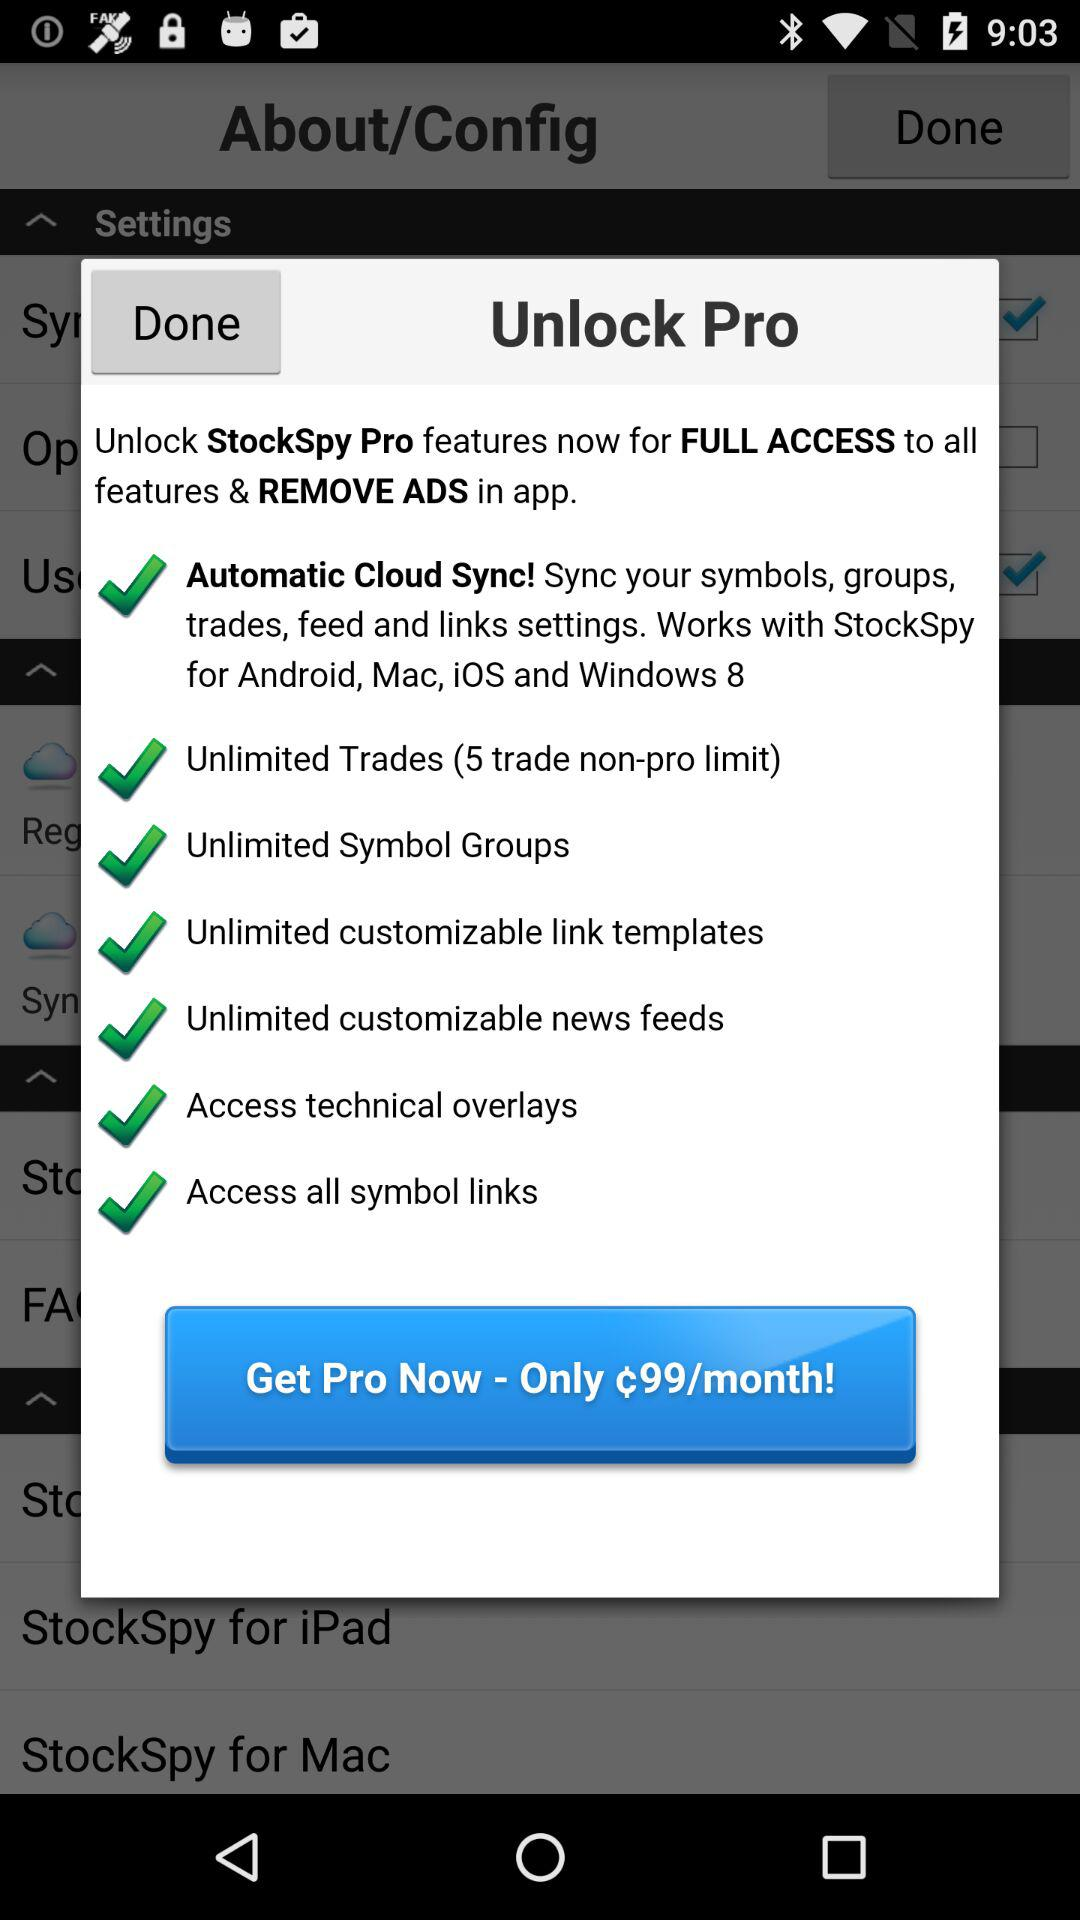What is the maximum number of trades for non-pro users? The maximum number of trades for non-pro users is 5. 